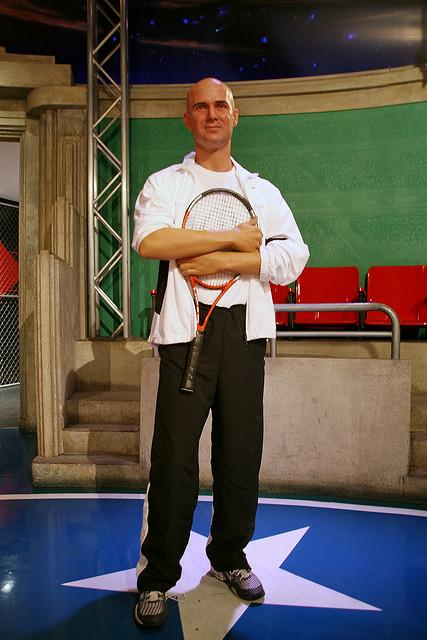What sports equipment is the man holding? tennis racket 